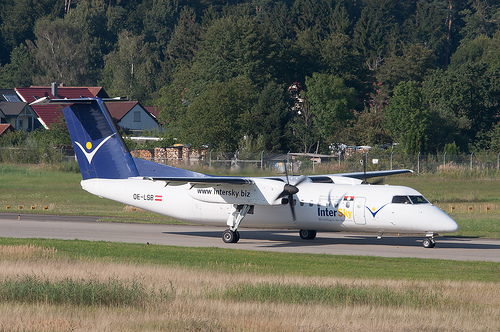Please provide the bounding box coordinate of the region this sentence describes: Landing gear wheels of airplane. The coordinates [0.42, 0.61, 0.5, 0.66] mark the region containing the 'Landing gear wheels of airplane,' critical for both takeoff and landing phases of flight. 